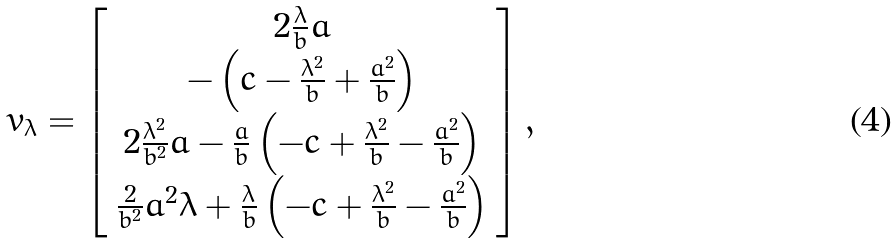<formula> <loc_0><loc_0><loc_500><loc_500>v _ { \lambda } = \left [ \begin{array} { c } 2 \frac { \lambda } { b } a \\ - \left ( c - \frac { \lambda ^ { 2 } } { b } + \frac { a ^ { 2 } } { b } \right ) \\ 2 \frac { \lambda ^ { 2 } } { b ^ { 2 } } a - \frac { a } { b } \left ( - c + \frac { \lambda ^ { 2 } } { b } - \frac { a ^ { 2 } } { b } \right ) \\ \frac { 2 } { b ^ { 2 } } a ^ { 2 } \lambda + \frac { \lambda } { b } \left ( - c + \frac { \lambda ^ { 2 } } { b } - \frac { a ^ { 2 } } { b } \right ) \end{array} \right ] ,</formula> 